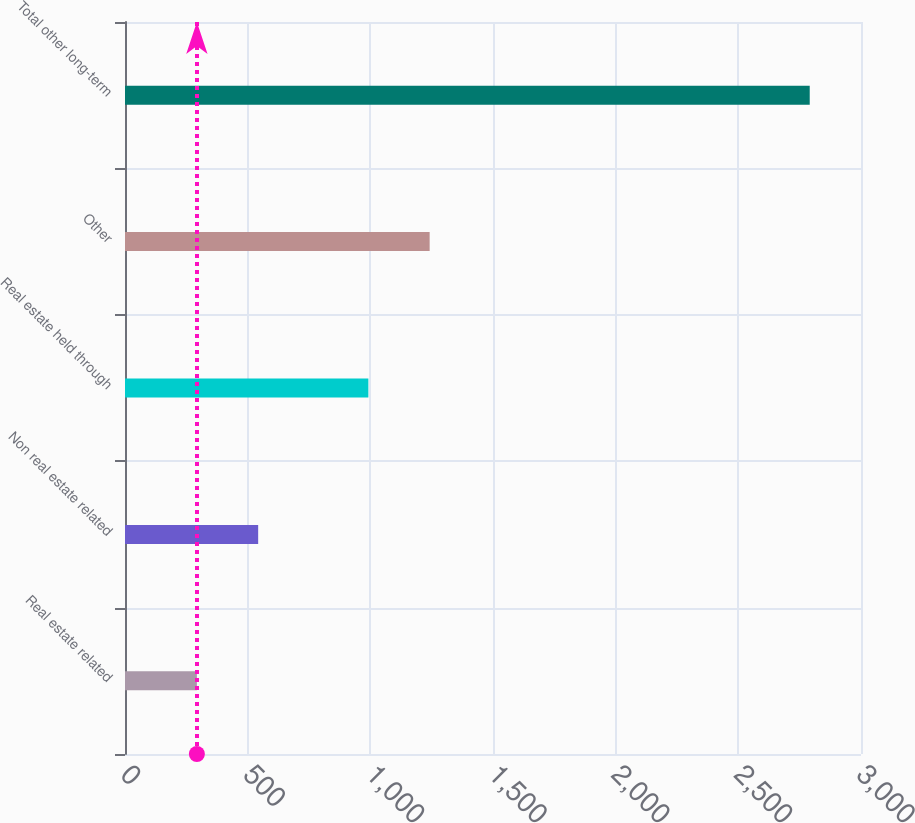Convert chart. <chart><loc_0><loc_0><loc_500><loc_500><bar_chart><fcel>Real estate related<fcel>Non real estate related<fcel>Real estate held through<fcel>Other<fcel>Total other long-term<nl><fcel>293<fcel>542.8<fcel>992<fcel>1241.8<fcel>2791<nl></chart> 